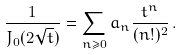Convert formula to latex. <formula><loc_0><loc_0><loc_500><loc_500>\frac { 1 } { J _ { 0 } ( 2 \sqrt { t } ) } = \sum _ { n \geq 0 } a _ { n } \frac { t ^ { n } } { ( n ! ) ^ { 2 } } \, .</formula> 